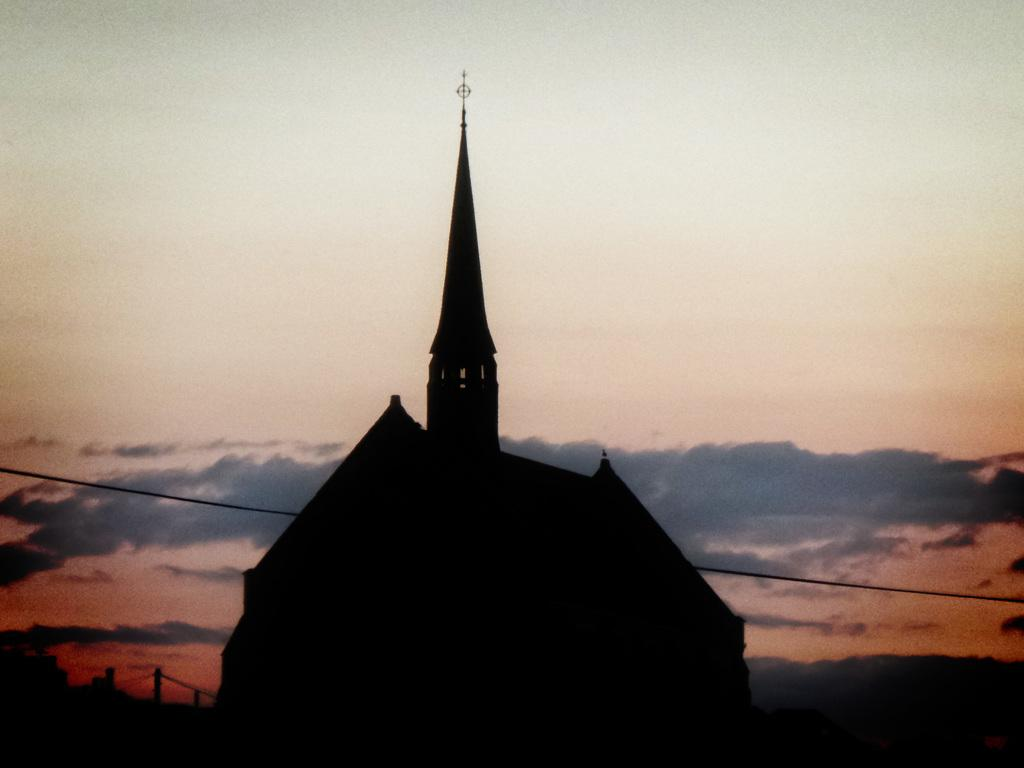What type of structure is visible in the image? There is a house in the image. What else can be seen in the image besides the house? There is a wire visible in the image. What is visible in the background of the image? The sky is visible in the background of the image. What type of drum can be heard playing in the background of the image? There is no drum present in the image, and therefore no sound can be heard. 